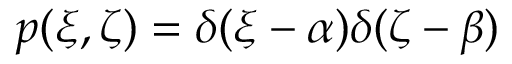<formula> <loc_0><loc_0><loc_500><loc_500>p ( \xi , \zeta ) = \delta ( \xi - \alpha ) \delta ( \zeta - \beta )</formula> 